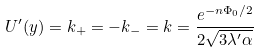<formula> <loc_0><loc_0><loc_500><loc_500>U ^ { \prime } ( y ) = k _ { + } = - k _ { - } = k = \frac { e ^ { - n \Phi _ { 0 } / 2 } } { 2 \sqrt { 3 \lambda ^ { \prime } \alpha } }</formula> 